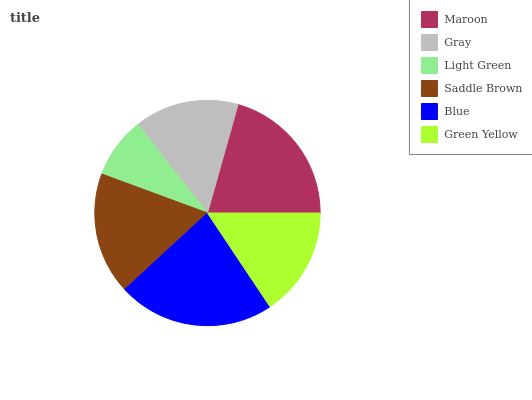Is Light Green the minimum?
Answer yes or no. Yes. Is Blue the maximum?
Answer yes or no. Yes. Is Gray the minimum?
Answer yes or no. No. Is Gray the maximum?
Answer yes or no. No. Is Maroon greater than Gray?
Answer yes or no. Yes. Is Gray less than Maroon?
Answer yes or no. Yes. Is Gray greater than Maroon?
Answer yes or no. No. Is Maroon less than Gray?
Answer yes or no. No. Is Saddle Brown the high median?
Answer yes or no. Yes. Is Green Yellow the low median?
Answer yes or no. Yes. Is Light Green the high median?
Answer yes or no. No. Is Light Green the low median?
Answer yes or no. No. 